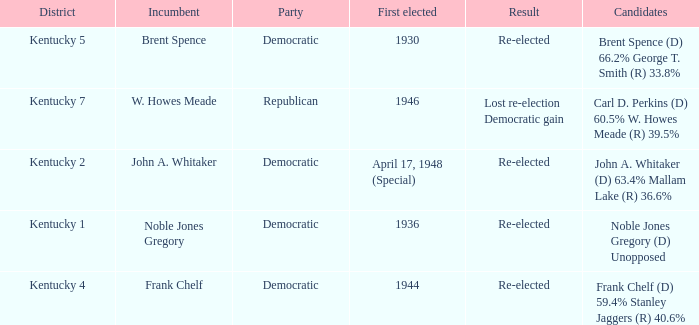List all candidates in the democratic party where the election had the incumbent Frank Chelf running. Frank Chelf (D) 59.4% Stanley Jaggers (R) 40.6%. 